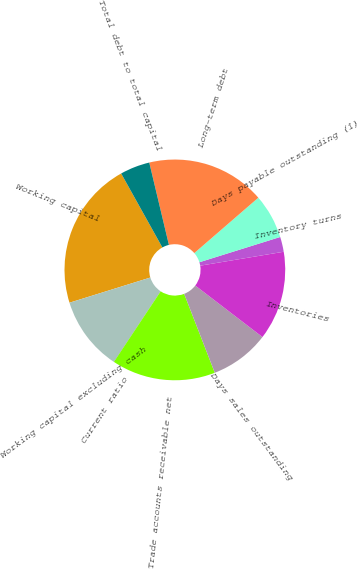Convert chart to OTSL. <chart><loc_0><loc_0><loc_500><loc_500><pie_chart><fcel>Working capital<fcel>Working capital excluding cash<fcel>Current ratio<fcel>Trade accounts receivable net<fcel>Days sales outstanding<fcel>Inventories<fcel>Inventory turns<fcel>Days payable outstanding (1)<fcel>Long-term debt<fcel>Total debt to total capital<nl><fcel>21.72%<fcel>10.87%<fcel>0.01%<fcel>15.21%<fcel>8.7%<fcel>13.04%<fcel>2.19%<fcel>6.53%<fcel>17.38%<fcel>4.36%<nl></chart> 